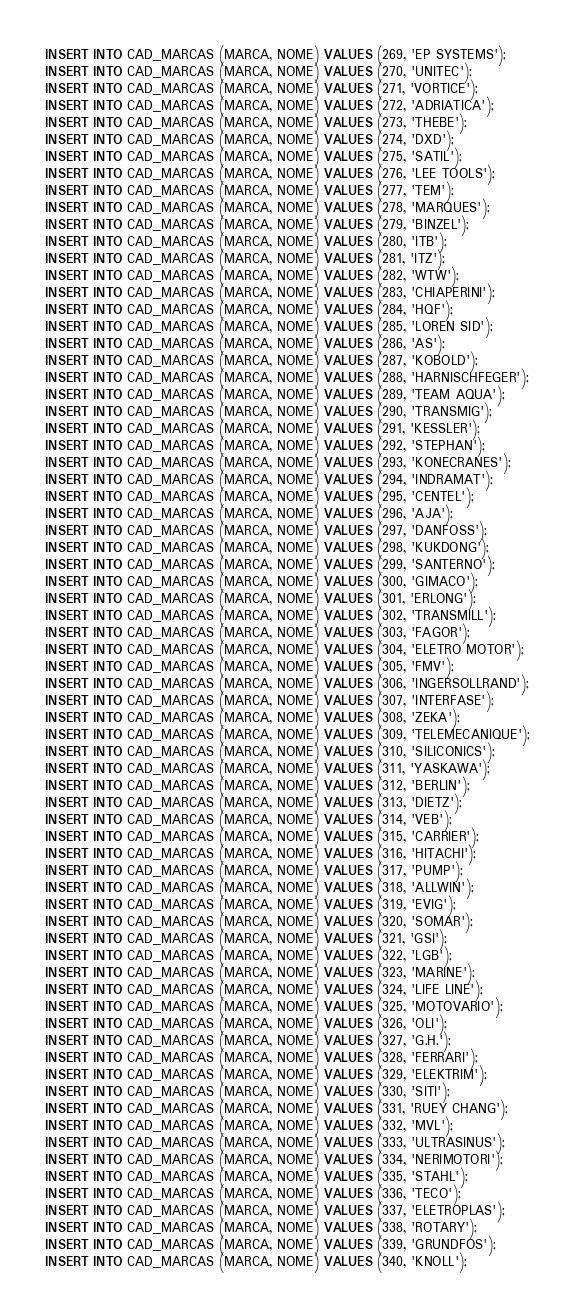Convert code to text. <code><loc_0><loc_0><loc_500><loc_500><_SQL_>INSERT INTO CAD_MARCAS (MARCA, NOME) VALUES (269, 'EP SYSTEMS');
INSERT INTO CAD_MARCAS (MARCA, NOME) VALUES (270, 'UNITEC');
INSERT INTO CAD_MARCAS (MARCA, NOME) VALUES (271, 'VORTICE');
INSERT INTO CAD_MARCAS (MARCA, NOME) VALUES (272, 'ADRIATICA');
INSERT INTO CAD_MARCAS (MARCA, NOME) VALUES (273, 'THEBE');
INSERT INTO CAD_MARCAS (MARCA, NOME) VALUES (274, 'DXD');
INSERT INTO CAD_MARCAS (MARCA, NOME) VALUES (275, 'SATIL');
INSERT INTO CAD_MARCAS (MARCA, NOME) VALUES (276, 'LEE TOOLS');
INSERT INTO CAD_MARCAS (MARCA, NOME) VALUES (277, 'TEM');
INSERT INTO CAD_MARCAS (MARCA, NOME) VALUES (278, 'MARQUES');
INSERT INTO CAD_MARCAS (MARCA, NOME) VALUES (279, 'BINZEL');
INSERT INTO CAD_MARCAS (MARCA, NOME) VALUES (280, 'ITB');
INSERT INTO CAD_MARCAS (MARCA, NOME) VALUES (281, 'ITZ');
INSERT INTO CAD_MARCAS (MARCA, NOME) VALUES (282, 'WTW');
INSERT INTO CAD_MARCAS (MARCA, NOME) VALUES (283, 'CHIAPERINI');
INSERT INTO CAD_MARCAS (MARCA, NOME) VALUES (284, 'HQF');
INSERT INTO CAD_MARCAS (MARCA, NOME) VALUES (285, 'LOREN SID');
INSERT INTO CAD_MARCAS (MARCA, NOME) VALUES (286, 'AS');
INSERT INTO CAD_MARCAS (MARCA, NOME) VALUES (287, 'KOBOLD');
INSERT INTO CAD_MARCAS (MARCA, NOME) VALUES (288, 'HARNISCHFEGER');
INSERT INTO CAD_MARCAS (MARCA, NOME) VALUES (289, 'TEAM AQUA');
INSERT INTO CAD_MARCAS (MARCA, NOME) VALUES (290, 'TRANSMIG');
INSERT INTO CAD_MARCAS (MARCA, NOME) VALUES (291, 'KESSLER');
INSERT INTO CAD_MARCAS (MARCA, NOME) VALUES (292, 'STEPHAN');
INSERT INTO CAD_MARCAS (MARCA, NOME) VALUES (293, 'KONECRANES');
INSERT INTO CAD_MARCAS (MARCA, NOME) VALUES (294, 'INDRAMAT');
INSERT INTO CAD_MARCAS (MARCA, NOME) VALUES (295, 'CENTEL');
INSERT INTO CAD_MARCAS (MARCA, NOME) VALUES (296, 'AJA');
INSERT INTO CAD_MARCAS (MARCA, NOME) VALUES (297, 'DANFOSS');
INSERT INTO CAD_MARCAS (MARCA, NOME) VALUES (298, 'KUKDONG');
INSERT INTO CAD_MARCAS (MARCA, NOME) VALUES (299, 'SANTERNO');
INSERT INTO CAD_MARCAS (MARCA, NOME) VALUES (300, 'GIMACO');
INSERT INTO CAD_MARCAS (MARCA, NOME) VALUES (301, 'ERLONG');
INSERT INTO CAD_MARCAS (MARCA, NOME) VALUES (302, 'TRANSMILL');
INSERT INTO CAD_MARCAS (MARCA, NOME) VALUES (303, 'FAGOR');
INSERT INTO CAD_MARCAS (MARCA, NOME) VALUES (304, 'ELETRO MOTOR');
INSERT INTO CAD_MARCAS (MARCA, NOME) VALUES (305, 'FMV');
INSERT INTO CAD_MARCAS (MARCA, NOME) VALUES (306, 'INGERSOLLRAND');
INSERT INTO CAD_MARCAS (MARCA, NOME) VALUES (307, 'INTERFASE');
INSERT INTO CAD_MARCAS (MARCA, NOME) VALUES (308, 'ZEKA');
INSERT INTO CAD_MARCAS (MARCA, NOME) VALUES (309, 'TELEMECANIQUE');
INSERT INTO CAD_MARCAS (MARCA, NOME) VALUES (310, 'SILICONICS');
INSERT INTO CAD_MARCAS (MARCA, NOME) VALUES (311, 'YASKAWA');
INSERT INTO CAD_MARCAS (MARCA, NOME) VALUES (312, 'BERLIN');
INSERT INTO CAD_MARCAS (MARCA, NOME) VALUES (313, 'DIETZ');
INSERT INTO CAD_MARCAS (MARCA, NOME) VALUES (314, 'VEB');
INSERT INTO CAD_MARCAS (MARCA, NOME) VALUES (315, 'CARRIER');
INSERT INTO CAD_MARCAS (MARCA, NOME) VALUES (316, 'HITACHI');
INSERT INTO CAD_MARCAS (MARCA, NOME) VALUES (317, 'PUMP');
INSERT INTO CAD_MARCAS (MARCA, NOME) VALUES (318, 'ALLWIN');
INSERT INTO CAD_MARCAS (MARCA, NOME) VALUES (319, 'EVIG');
INSERT INTO CAD_MARCAS (MARCA, NOME) VALUES (320, 'SOMAR');
INSERT INTO CAD_MARCAS (MARCA, NOME) VALUES (321, 'GSI');
INSERT INTO CAD_MARCAS (MARCA, NOME) VALUES (322, 'LGB');
INSERT INTO CAD_MARCAS (MARCA, NOME) VALUES (323, 'MARINE');
INSERT INTO CAD_MARCAS (MARCA, NOME) VALUES (324, 'LIFE LINE');
INSERT INTO CAD_MARCAS (MARCA, NOME) VALUES (325, 'MOTOVARIO');
INSERT INTO CAD_MARCAS (MARCA, NOME) VALUES (326, 'OLI');
INSERT INTO CAD_MARCAS (MARCA, NOME) VALUES (327, 'G.H.');
INSERT INTO CAD_MARCAS (MARCA, NOME) VALUES (328, 'FERRARI');
INSERT INTO CAD_MARCAS (MARCA, NOME) VALUES (329, 'ELEKTRIM');
INSERT INTO CAD_MARCAS (MARCA, NOME) VALUES (330, 'SITI');
INSERT INTO CAD_MARCAS (MARCA, NOME) VALUES (331, 'RUEY CHANG');
INSERT INTO CAD_MARCAS (MARCA, NOME) VALUES (332, 'MVL');
INSERT INTO CAD_MARCAS (MARCA, NOME) VALUES (333, 'ULTRASINUS');
INSERT INTO CAD_MARCAS (MARCA, NOME) VALUES (334, 'NERIMOTORI');
INSERT INTO CAD_MARCAS (MARCA, NOME) VALUES (335, 'STAHL');
INSERT INTO CAD_MARCAS (MARCA, NOME) VALUES (336, 'TECO');
INSERT INTO CAD_MARCAS (MARCA, NOME) VALUES (337, 'ELETROPLAS');
INSERT INTO CAD_MARCAS (MARCA, NOME) VALUES (338, 'ROTARY');
INSERT INTO CAD_MARCAS (MARCA, NOME) VALUES (339, 'GRUNDFOS');
INSERT INTO CAD_MARCAS (MARCA, NOME) VALUES (340, 'KNOLL');</code> 